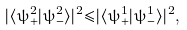<formula> <loc_0><loc_0><loc_500><loc_500>| { \langle } { \psi } ^ { 2 } _ { + } | { \psi } ^ { 2 } _ { - } { \rangle } | ^ { 2 } { \leq } | { \langle } { \psi } ^ { 1 } _ { + } | { \psi } ^ { 1 } _ { - } { \rangle } | ^ { 2 } ,</formula> 